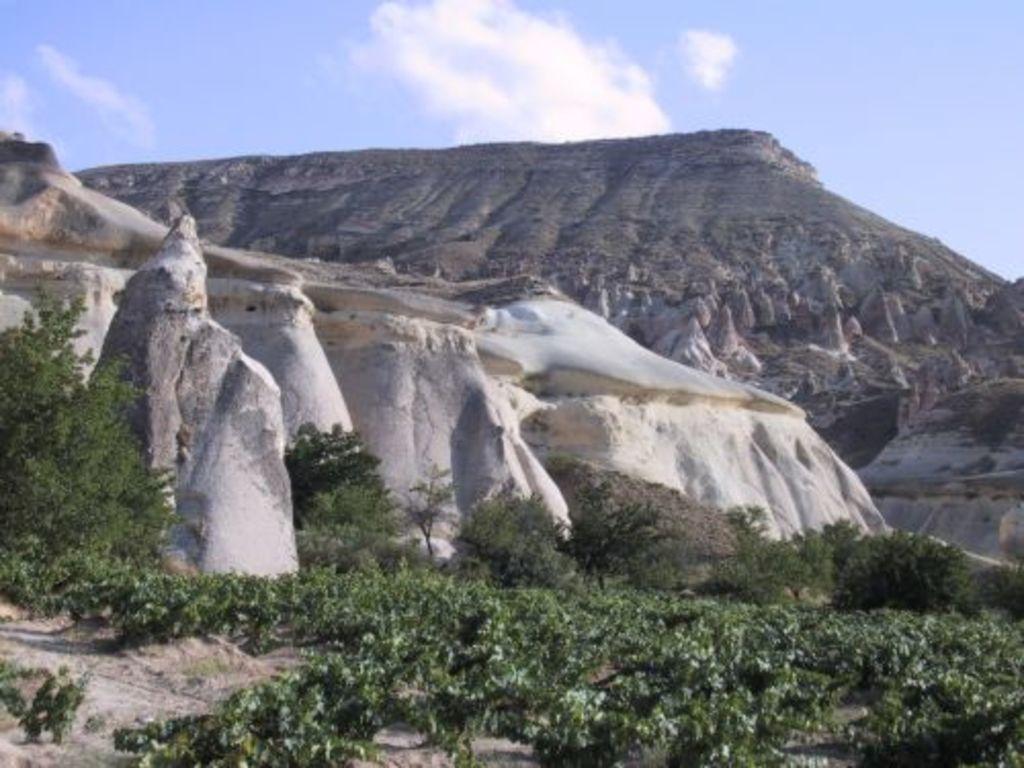Please provide a concise description of this image. In this picture I can see plants, trees, there are hills, and in the background there is sky. 